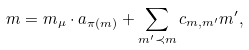<formula> <loc_0><loc_0><loc_500><loc_500>m = m _ { \mu } \cdot a _ { \pi ( m ) } + \sum _ { m ^ { \prime } \prec m } c _ { m , m ^ { \prime } } m ^ { \prime } ,</formula> 